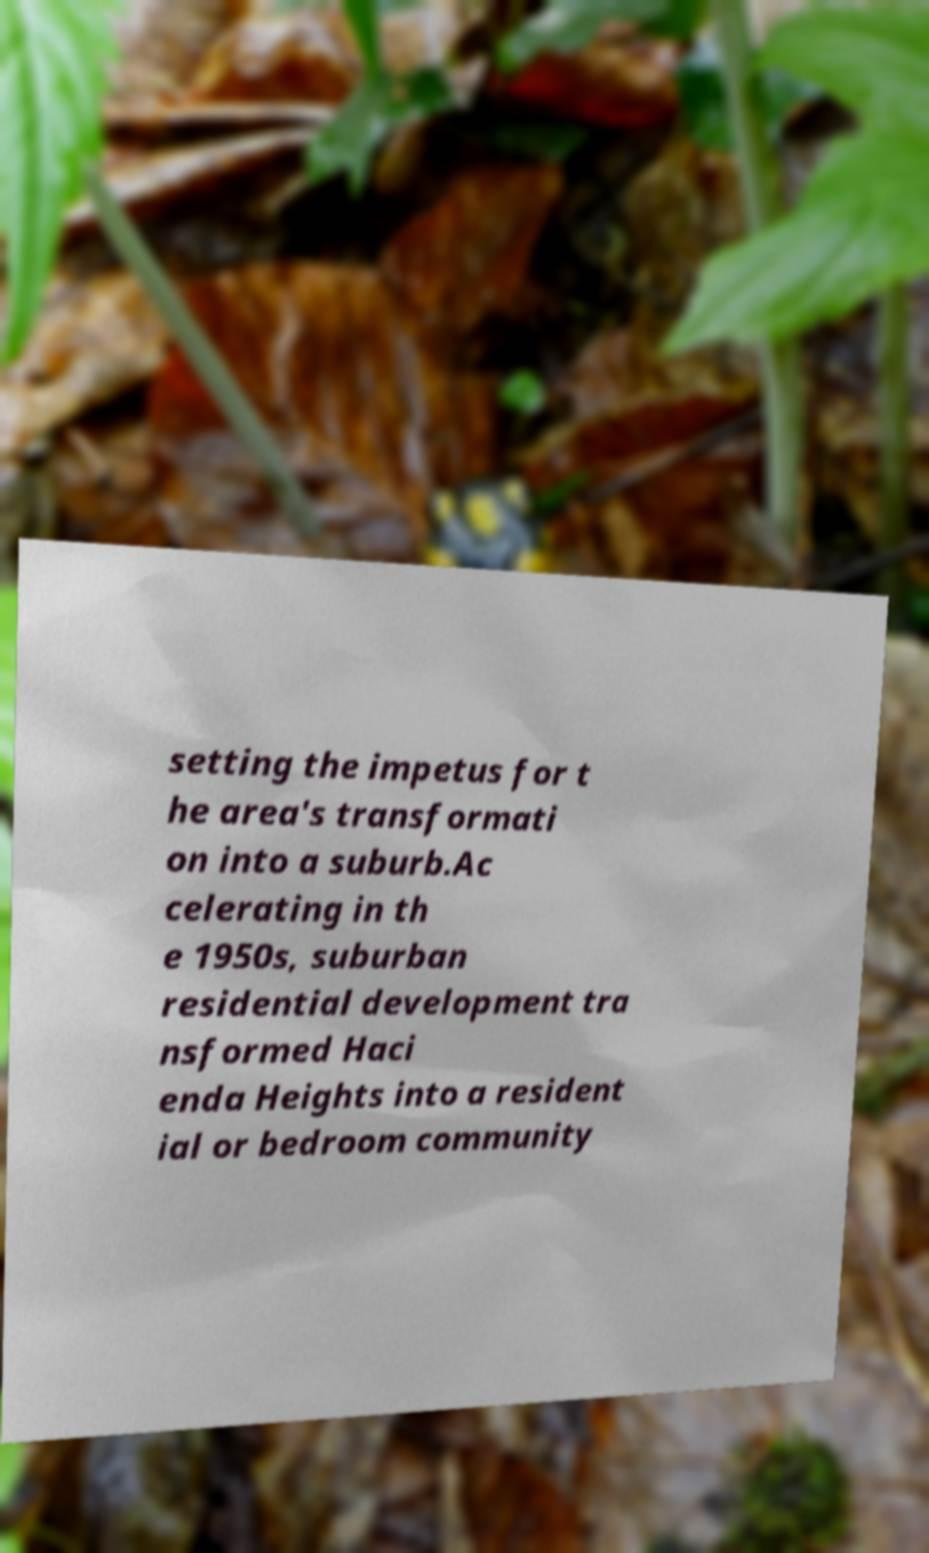I need the written content from this picture converted into text. Can you do that? setting the impetus for t he area's transformati on into a suburb.Ac celerating in th e 1950s, suburban residential development tra nsformed Haci enda Heights into a resident ial or bedroom community 